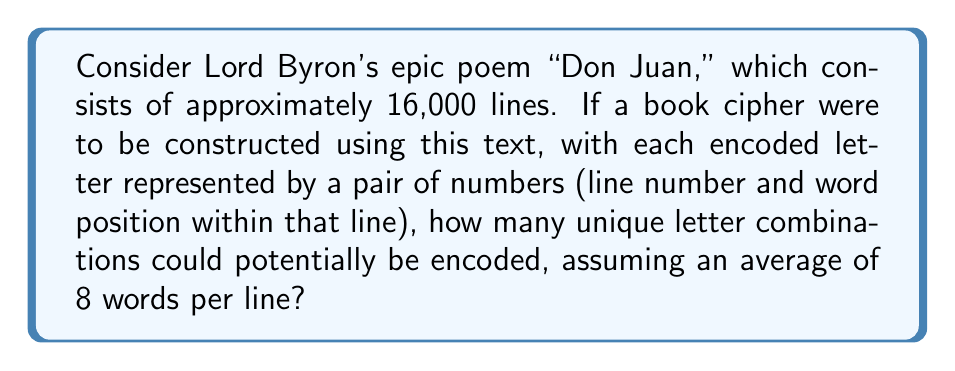Give your solution to this math problem. To solve this problem, we need to follow these steps:

1. Calculate the total number of words in the text:
   $$ \text{Total words} = \text{Number of lines} \times \text{Average words per line} $$
   $$ \text{Total words} = 16,000 \times 8 = 128,000 $$

2. In a book cipher, each letter is typically represented by a pair of numbers:
   - The line number (ranging from 1 to 16,000)
   - The word position within that line (ranging from 1 to 8)

3. The number of unique combinations is the product of these two ranges:
   $$ \text{Unique combinations} = \text{Number of lines} \times \text{Words per line} $$
   $$ \text{Unique combinations} = 16,000 \times 8 = 128,000 $$

4. This number represents the maximum number of unique letter combinations that could be encoded using this book cipher system.

5. It's worth noting that this is more than sufficient for encoding the 26 letters of the alphabet multiple times, allowing for various representations of each letter to improve security.
Answer: 128,000 unique combinations 